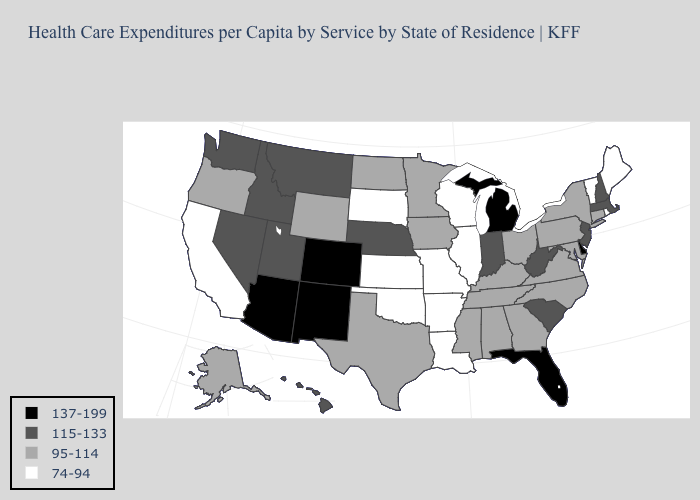Name the states that have a value in the range 74-94?
Be succinct. Arkansas, California, Illinois, Kansas, Louisiana, Maine, Missouri, Oklahoma, Rhode Island, South Dakota, Vermont, Wisconsin. Does New Mexico have the highest value in the West?
Quick response, please. Yes. Does Montana have the highest value in the West?
Quick response, please. No. Does the map have missing data?
Keep it brief. No. Which states have the highest value in the USA?
Short answer required. Arizona, Colorado, Delaware, Florida, Michigan, New Mexico. Among the states that border Connecticut , does Rhode Island have the lowest value?
Answer briefly. Yes. Among the states that border Connecticut , does Massachusetts have the highest value?
Short answer required. Yes. What is the value of Texas?
Keep it brief. 95-114. Is the legend a continuous bar?
Give a very brief answer. No. What is the lowest value in states that border Montana?
Answer briefly. 74-94. Name the states that have a value in the range 74-94?
Concise answer only. Arkansas, California, Illinois, Kansas, Louisiana, Maine, Missouri, Oklahoma, Rhode Island, South Dakota, Vermont, Wisconsin. Does the first symbol in the legend represent the smallest category?
Answer briefly. No. What is the highest value in the MidWest ?
Be succinct. 137-199. What is the lowest value in states that border Kentucky?
Keep it brief. 74-94. Does the first symbol in the legend represent the smallest category?
Write a very short answer. No. 